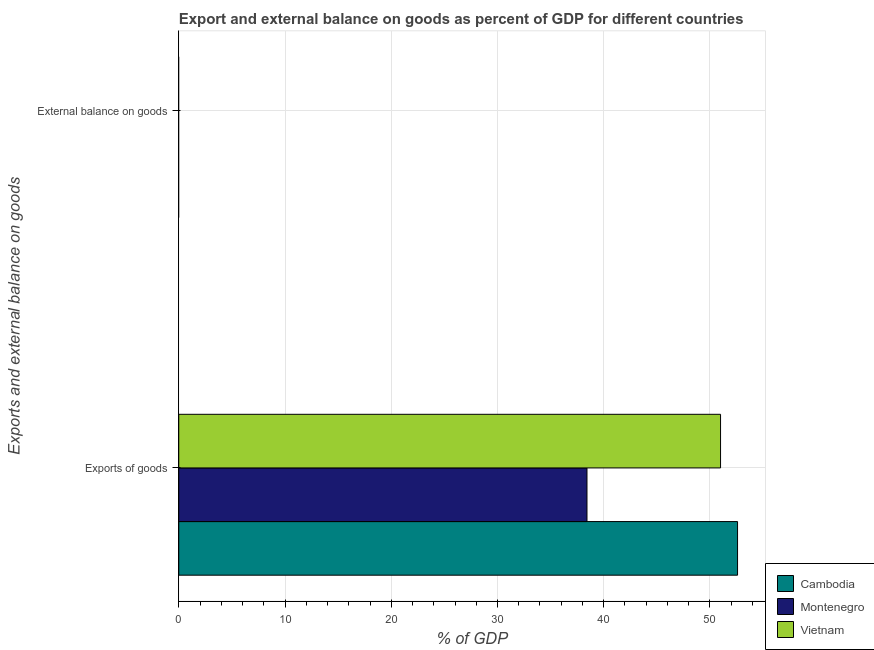Are the number of bars on each tick of the Y-axis equal?
Your answer should be compact. No. How many bars are there on the 2nd tick from the top?
Make the answer very short. 3. What is the label of the 1st group of bars from the top?
Provide a short and direct response. External balance on goods. What is the export of goods as percentage of gdp in Montenegro?
Keep it short and to the point. 38.42. Across all countries, what is the maximum export of goods as percentage of gdp?
Provide a short and direct response. 52.6. In which country was the export of goods as percentage of gdp maximum?
Offer a very short reply. Cambodia. What is the difference between the export of goods as percentage of gdp in Cambodia and that in Montenegro?
Your answer should be compact. 14.17. What is the difference between the external balance on goods as percentage of gdp in Montenegro and the export of goods as percentage of gdp in Vietnam?
Provide a succinct answer. -51. What is the average export of goods as percentage of gdp per country?
Your answer should be compact. 47.34. What is the ratio of the export of goods as percentage of gdp in Montenegro to that in Vietnam?
Keep it short and to the point. 0.75. Is the export of goods as percentage of gdp in Montenegro less than that in Vietnam?
Your answer should be compact. Yes. In how many countries, is the external balance on goods as percentage of gdp greater than the average external balance on goods as percentage of gdp taken over all countries?
Give a very brief answer. 0. How many countries are there in the graph?
Offer a terse response. 3. What is the difference between two consecutive major ticks on the X-axis?
Ensure brevity in your answer.  10. What is the title of the graph?
Ensure brevity in your answer.  Export and external balance on goods as percent of GDP for different countries. What is the label or title of the X-axis?
Your answer should be compact. % of GDP. What is the label or title of the Y-axis?
Offer a very short reply. Exports and external balance on goods. What is the % of GDP in Cambodia in Exports of goods?
Keep it short and to the point. 52.6. What is the % of GDP of Montenegro in Exports of goods?
Provide a succinct answer. 38.42. What is the % of GDP of Vietnam in Exports of goods?
Provide a succinct answer. 51. What is the % of GDP of Montenegro in External balance on goods?
Give a very brief answer. 0. What is the % of GDP in Vietnam in External balance on goods?
Your answer should be very brief. 0. Across all Exports and external balance on goods, what is the maximum % of GDP of Cambodia?
Provide a succinct answer. 52.6. Across all Exports and external balance on goods, what is the maximum % of GDP in Montenegro?
Make the answer very short. 38.42. Across all Exports and external balance on goods, what is the maximum % of GDP in Vietnam?
Make the answer very short. 51. Across all Exports and external balance on goods, what is the minimum % of GDP in Cambodia?
Your answer should be compact. 0. What is the total % of GDP of Cambodia in the graph?
Give a very brief answer. 52.6. What is the total % of GDP in Montenegro in the graph?
Keep it short and to the point. 38.42. What is the total % of GDP in Vietnam in the graph?
Offer a very short reply. 51. What is the average % of GDP of Cambodia per Exports and external balance on goods?
Ensure brevity in your answer.  26.3. What is the average % of GDP of Montenegro per Exports and external balance on goods?
Ensure brevity in your answer.  19.21. What is the average % of GDP of Vietnam per Exports and external balance on goods?
Your answer should be very brief. 25.5. What is the difference between the % of GDP in Cambodia and % of GDP in Montenegro in Exports of goods?
Ensure brevity in your answer.  14.17. What is the difference between the % of GDP in Cambodia and % of GDP in Vietnam in Exports of goods?
Make the answer very short. 1.6. What is the difference between the % of GDP of Montenegro and % of GDP of Vietnam in Exports of goods?
Your answer should be very brief. -12.57. What is the difference between the highest and the lowest % of GDP of Cambodia?
Offer a terse response. 52.6. What is the difference between the highest and the lowest % of GDP in Montenegro?
Your response must be concise. 38.42. What is the difference between the highest and the lowest % of GDP of Vietnam?
Give a very brief answer. 51. 